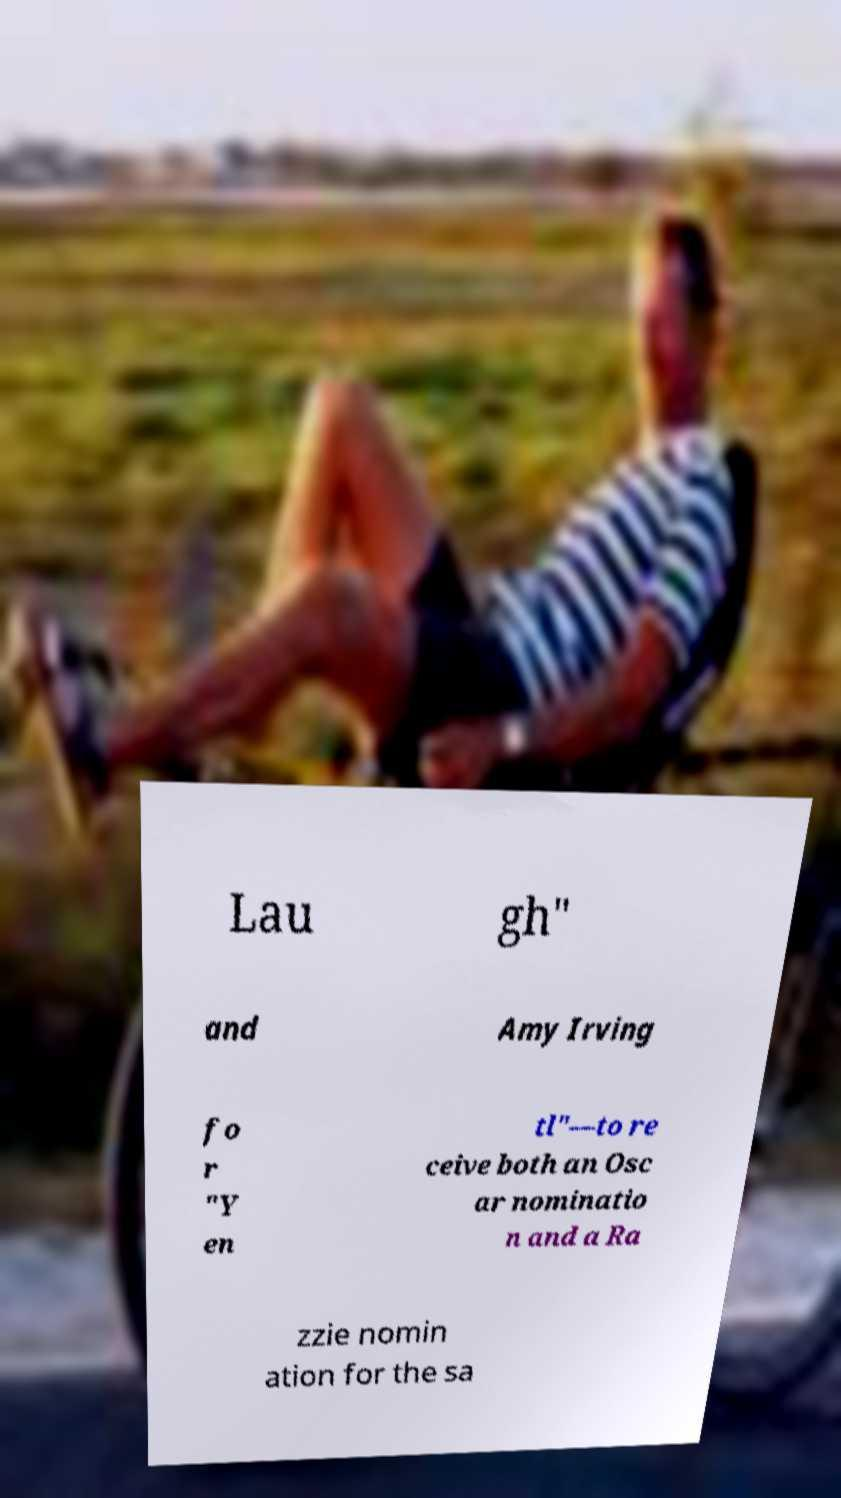Could you assist in decoding the text presented in this image and type it out clearly? Lau gh" and Amy Irving fo r "Y en tl"—to re ceive both an Osc ar nominatio n and a Ra zzie nomin ation for the sa 